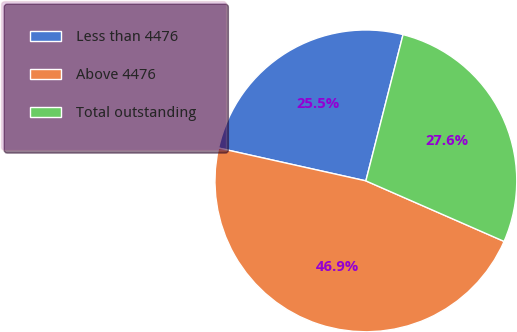Convert chart. <chart><loc_0><loc_0><loc_500><loc_500><pie_chart><fcel>Less than 4476<fcel>Above 4476<fcel>Total outstanding<nl><fcel>25.47%<fcel>46.92%<fcel>27.61%<nl></chart> 